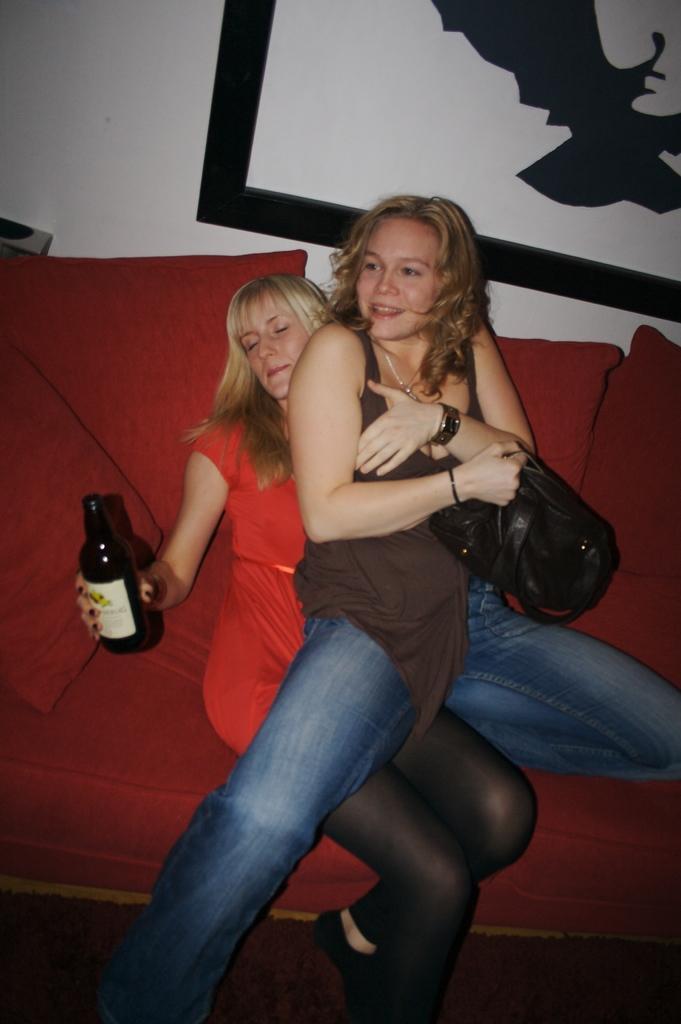Please provide a concise description of this image. This image consists of two women sitting on a sofa. The woman wearing a brown colour dress is sitting on the lap of the woman behind her. The sofa is red in colour. In the background there is a wall with the painting. The woman in the red colour dress is holding bottle in her hand and the woman wearing a brown colour dress is holding a black colour back. 